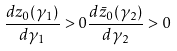Convert formula to latex. <formula><loc_0><loc_0><loc_500><loc_500>\frac { d z _ { 0 } ( \gamma _ { 1 } ) } { d \gamma _ { 1 } } > 0 \frac { d \bar { z } _ { 0 } ( \gamma _ { 2 } ) } { d \gamma _ { 2 } } > 0</formula> 